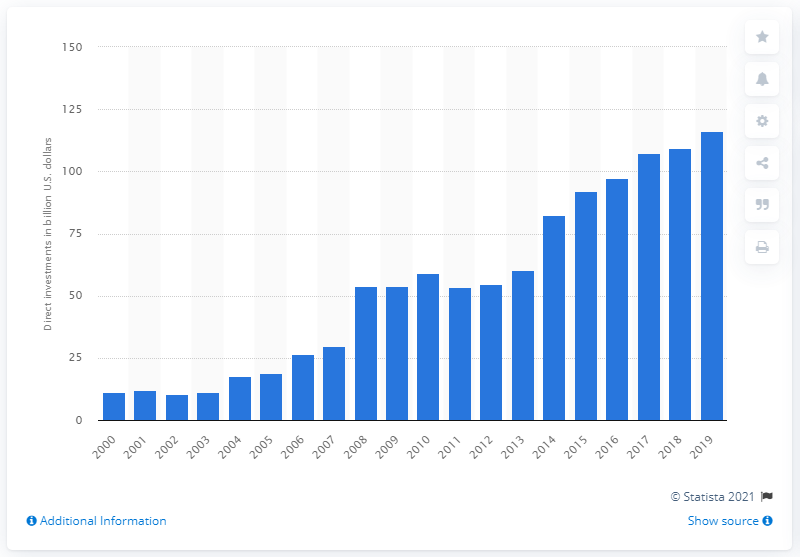List a handful of essential elements in this visual. In 2019, the United States invested a significant sum of money in China, totaling 116.2 billion dollars. 